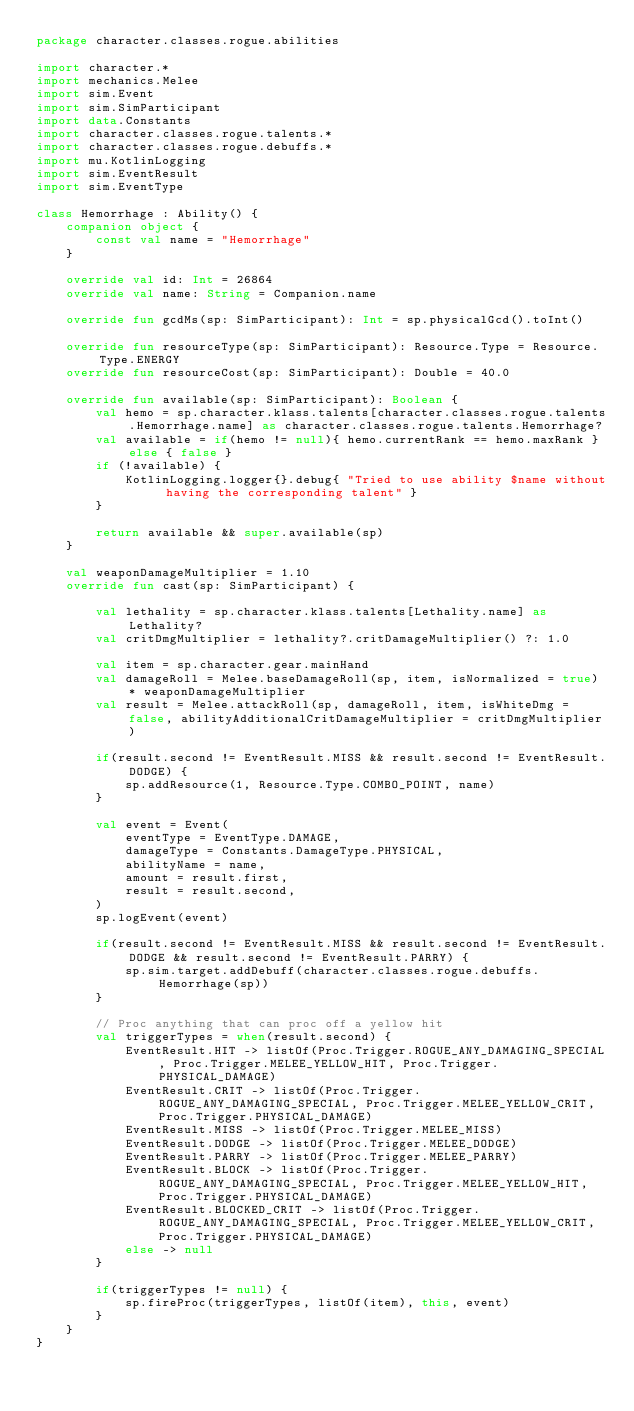<code> <loc_0><loc_0><loc_500><loc_500><_Kotlin_>package character.classes.rogue.abilities

import character.*
import mechanics.Melee
import sim.Event
import sim.SimParticipant
import data.Constants
import character.classes.rogue.talents.*
import character.classes.rogue.debuffs.*
import mu.KotlinLogging
import sim.EventResult
import sim.EventType

class Hemorrhage : Ability() {
    companion object {
        const val name = "Hemorrhage"
    }

    override val id: Int = 26864
    override val name: String = Companion.name

    override fun gcdMs(sp: SimParticipant): Int = sp.physicalGcd().toInt()

    override fun resourceType(sp: SimParticipant): Resource.Type = Resource.Type.ENERGY
    override fun resourceCost(sp: SimParticipant): Double = 40.0

    override fun available(sp: SimParticipant): Boolean {
        val hemo = sp.character.klass.talents[character.classes.rogue.talents.Hemorrhage.name] as character.classes.rogue.talents.Hemorrhage?
        val available = if(hemo != null){ hemo.currentRank == hemo.maxRank } else { false }
        if (!available) {
            KotlinLogging.logger{}.debug{ "Tried to use ability $name without having the corresponding talent" }
        }

        return available && super.available(sp)
    }

    val weaponDamageMultiplier = 1.10
    override fun cast(sp: SimParticipant) {

        val lethality = sp.character.klass.talents[Lethality.name] as Lethality?
        val critDmgMultiplier = lethality?.critDamageMultiplier() ?: 1.0

        val item = sp.character.gear.mainHand
        val damageRoll = Melee.baseDamageRoll(sp, item, isNormalized = true) * weaponDamageMultiplier
        val result = Melee.attackRoll(sp, damageRoll, item, isWhiteDmg = false, abilityAdditionalCritDamageMultiplier = critDmgMultiplier)

        if(result.second != EventResult.MISS && result.second != EventResult.DODGE) {
            sp.addResource(1, Resource.Type.COMBO_POINT, name)
        }

        val event = Event(
            eventType = EventType.DAMAGE,
            damageType = Constants.DamageType.PHYSICAL,
            abilityName = name,
            amount = result.first,
            result = result.second,
        )
        sp.logEvent(event)

        if(result.second != EventResult.MISS && result.second != EventResult.DODGE && result.second != EventResult.PARRY) {
            sp.sim.target.addDebuff(character.classes.rogue.debuffs.Hemorrhage(sp))
        }

        // Proc anything that can proc off a yellow hit
        val triggerTypes = when(result.second) {
            EventResult.HIT -> listOf(Proc.Trigger.ROGUE_ANY_DAMAGING_SPECIAL, Proc.Trigger.MELEE_YELLOW_HIT, Proc.Trigger.PHYSICAL_DAMAGE)
            EventResult.CRIT -> listOf(Proc.Trigger.ROGUE_ANY_DAMAGING_SPECIAL, Proc.Trigger.MELEE_YELLOW_CRIT, Proc.Trigger.PHYSICAL_DAMAGE)
            EventResult.MISS -> listOf(Proc.Trigger.MELEE_MISS)
            EventResult.DODGE -> listOf(Proc.Trigger.MELEE_DODGE)
            EventResult.PARRY -> listOf(Proc.Trigger.MELEE_PARRY)
            EventResult.BLOCK -> listOf(Proc.Trigger.ROGUE_ANY_DAMAGING_SPECIAL, Proc.Trigger.MELEE_YELLOW_HIT, Proc.Trigger.PHYSICAL_DAMAGE)
            EventResult.BLOCKED_CRIT -> listOf(Proc.Trigger.ROGUE_ANY_DAMAGING_SPECIAL, Proc.Trigger.MELEE_YELLOW_CRIT, Proc.Trigger.PHYSICAL_DAMAGE)
            else -> null
        }

        if(triggerTypes != null) {
            sp.fireProc(triggerTypes, listOf(item), this, event)
        }
    }
}
</code> 